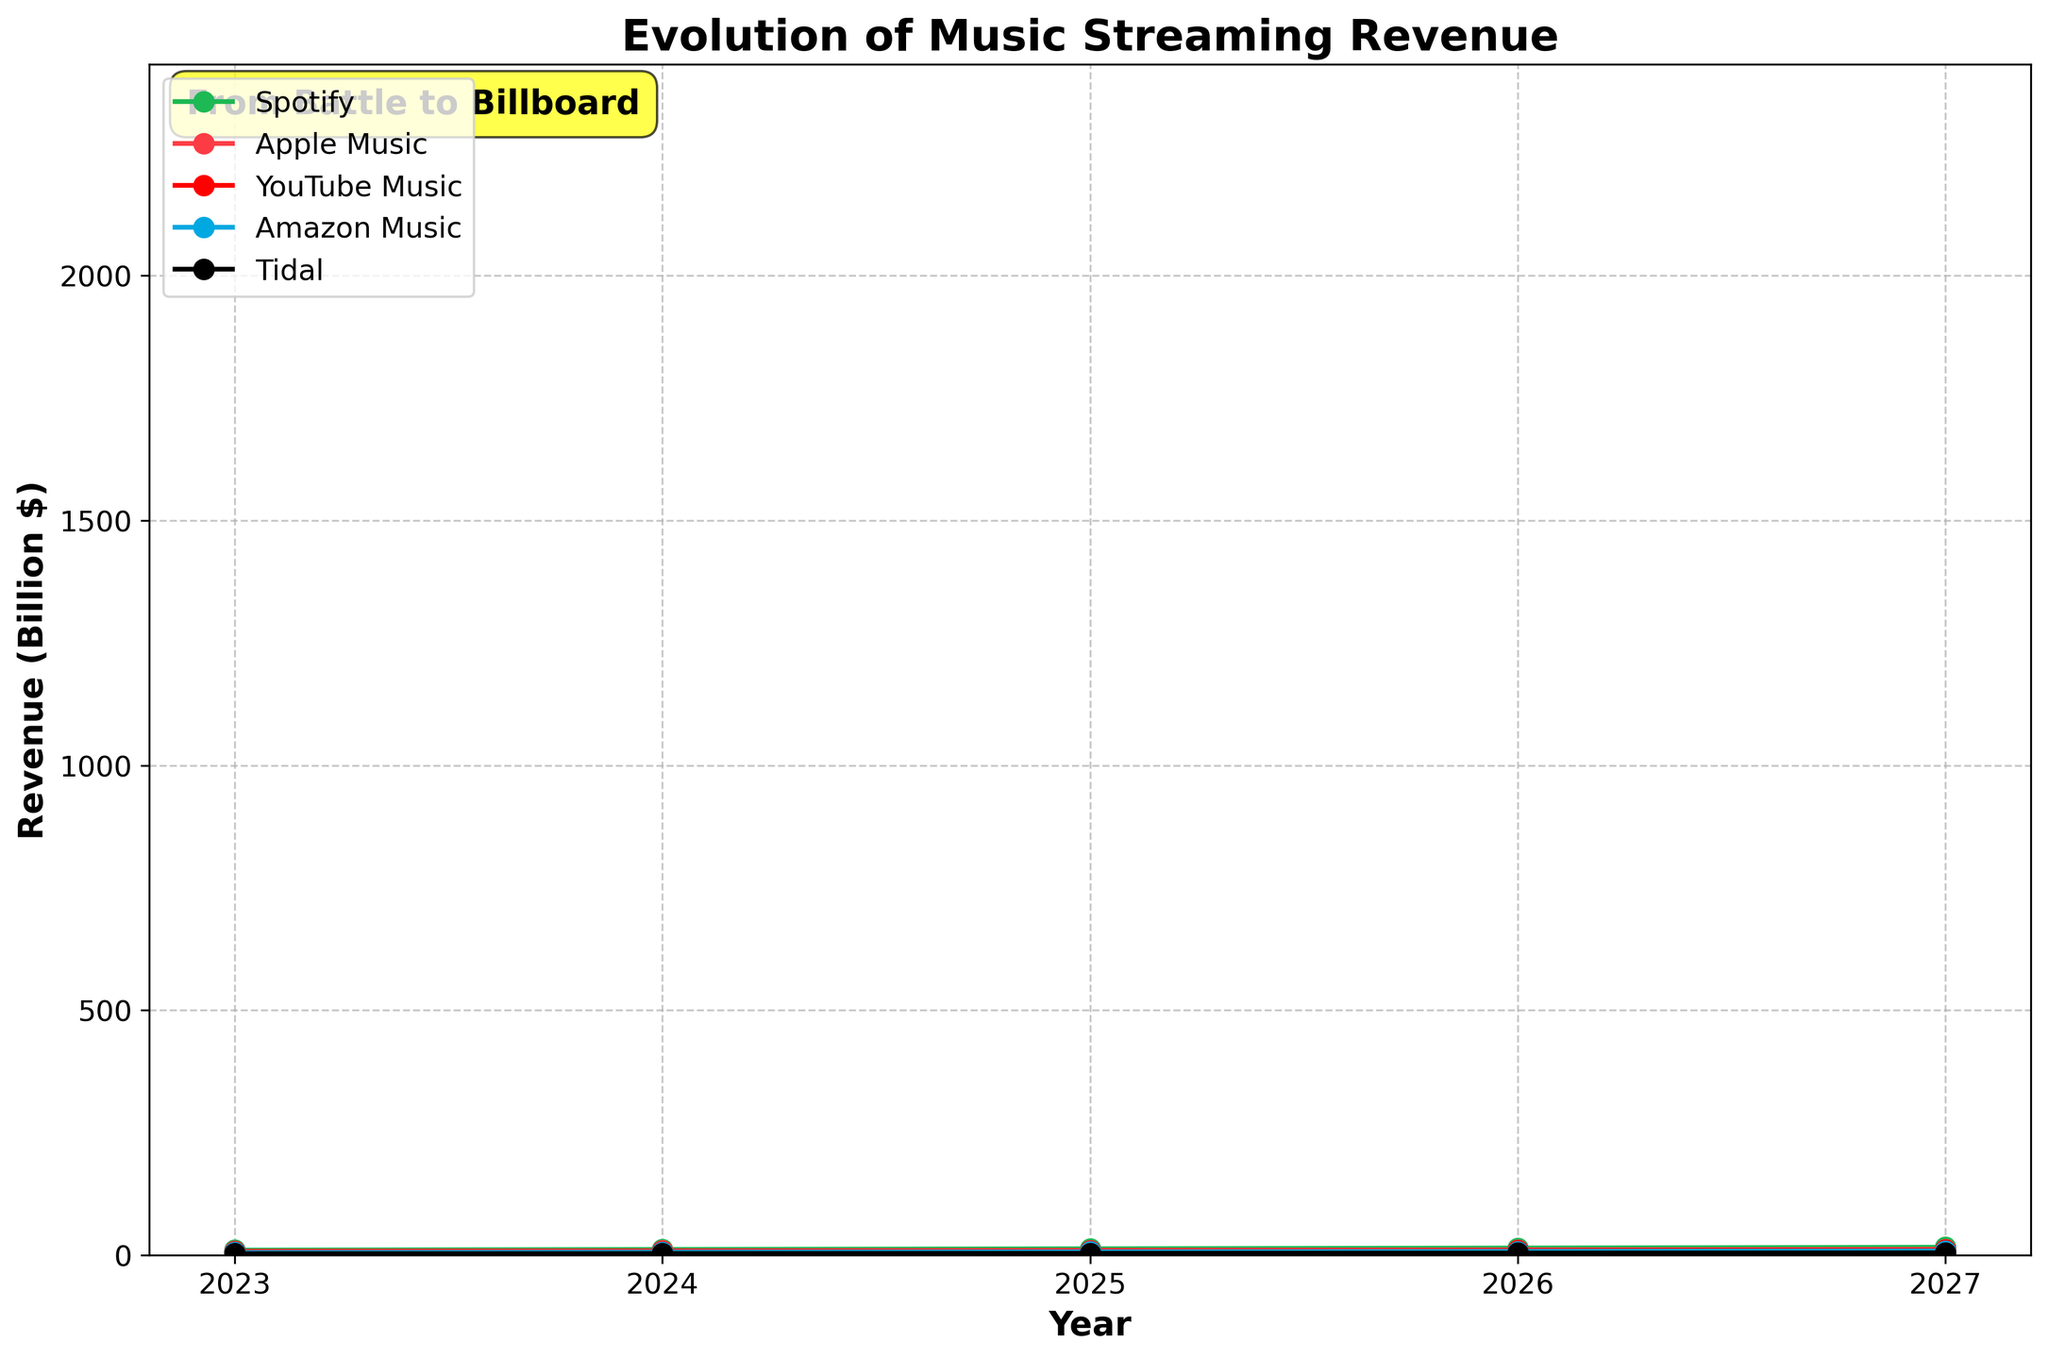What is the time period shown in the chart? The x-axis represents the years, spanning from 2023 to 2027. Thus, the chart covers a period of 5 years.
Answer: 5 years Which music streaming platform had the highest revenue in 2023? By looking at the data points for the year 2023, Spotify has the highest revenue at 10.5 billion dollars.
Answer: Spotify By how much did Apple Music's revenue increase from 2024 to 2026? The revenue for Apple Music in 2024 is 9.1 billion dollars and in 2026 is 11.0 billion dollars. The increase is calculated as 11.0 - 9.1 = 1.9 billion dollars.
Answer: 1.9 billion dollars In 2027, how does YouTube Music's revenue compare to Amazon Music's revenue? In 2027, YouTube Music's revenue is 10.2 billion dollars, while Amazon Music's revenue is 8.7 billion dollars. YouTube Music's revenue is higher.
Answer: YouTube Music's revenue is higher Which platform shows the greatest increase in revenue over the 5 years? By comparing the revenue values at the start (2023) and the end (2027) for each platform, we see: - Spotify: 16.3 - 10.5 = 5.8 - Apple Music: 12.1 - 8.2 = 3.9 - YouTube Music: 10.2 - 6.8 = 3.4 - Amazon Music: 8.7 - 5.5 = 3.2 - Tidal: 5.0 - 3.2 = 1.8 Spotify shows the greatest increase of 5.8 billion dollars.
Answer: Spotify What was the revenue for Spotify in 2025 and how do its values compare within the shaded fan effect area? The revenue for Spotify in 2025 is 13.2 billion dollars. Within the fan effect, this value should fall between 13.2 * 0.9 = 11.88 and 13.2 * 1.1 = 14.52 billion dollars.
Answer: Between 11.88 and 14.52 billion dollars If the trend continues, predict the revenue range for Tidal in 2028 using the fan effect margin. In 2027, Tidal's revenue is 5.0 billion dollars. Using the fan effect margin of ±10%, we project Tidal's revenue to be between 5.0 * 0.9 = 4.5 and 5.0 * 1.1 = 5.5 billion dollars in 2028.
Answer: Between 4.5 and 5.5 billion dollars How does the growth trend of Amazon Music compare to that of Tidal over the years? Comparing the increase from 2023 to 2027: - Amazon Music: 8.7 - 5.5 = 3.2 billion dollars - Tidal: 5.0 - 3.2 = 1.8 billion dollars Amazon Music shows a higher growth trend compared to Tidal.
Answer: Amazon Music has a higher growth trend Which year shows the smallest difference in revenue between Apple Music and YouTube Music, and what is that difference? Calculating the differences: - 2023: 8.2 - 6.8 = 1.4 - 2024: 9.1 - 7.5 = 1.6 - 2025: 10.0 - 8.3 = 1.7 - 2026: 11.0 - 9.2 = 1.8 - 2027: 12.1 - 10.2 = 1.9 The smallest difference is in 2023, which is 1.4 billion dollars.
Answer: 2023 and 1.4 billion dollars 